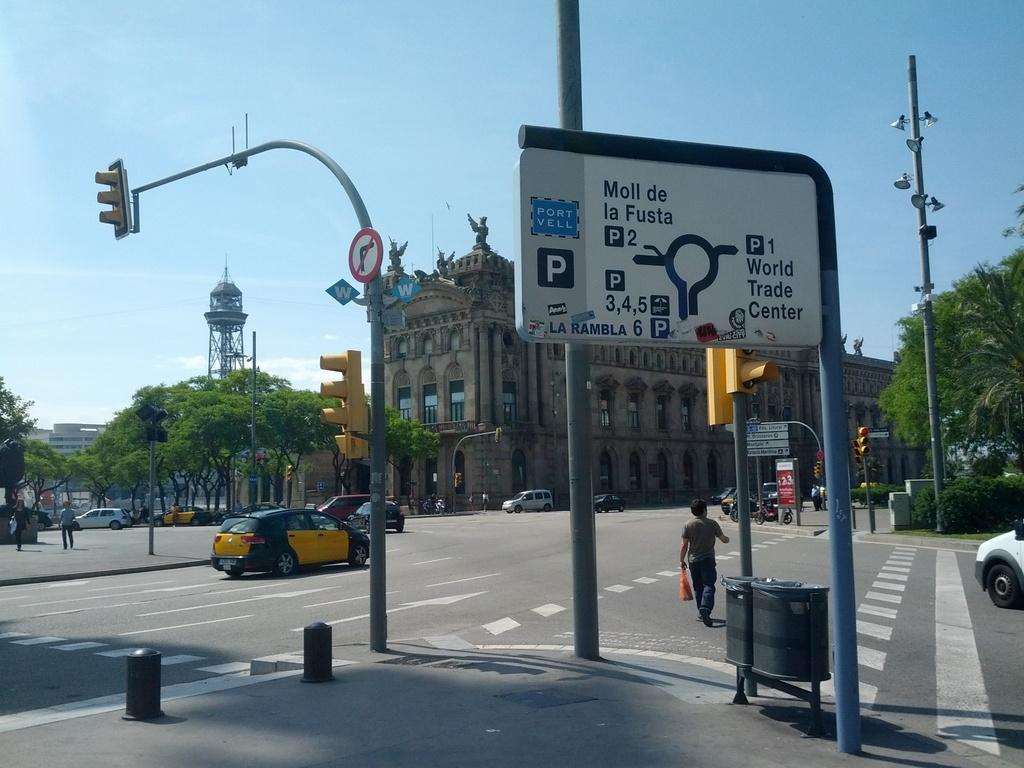<image>
Summarize the visual content of the image. White sign on the street which says "Moll de la Fusta". 